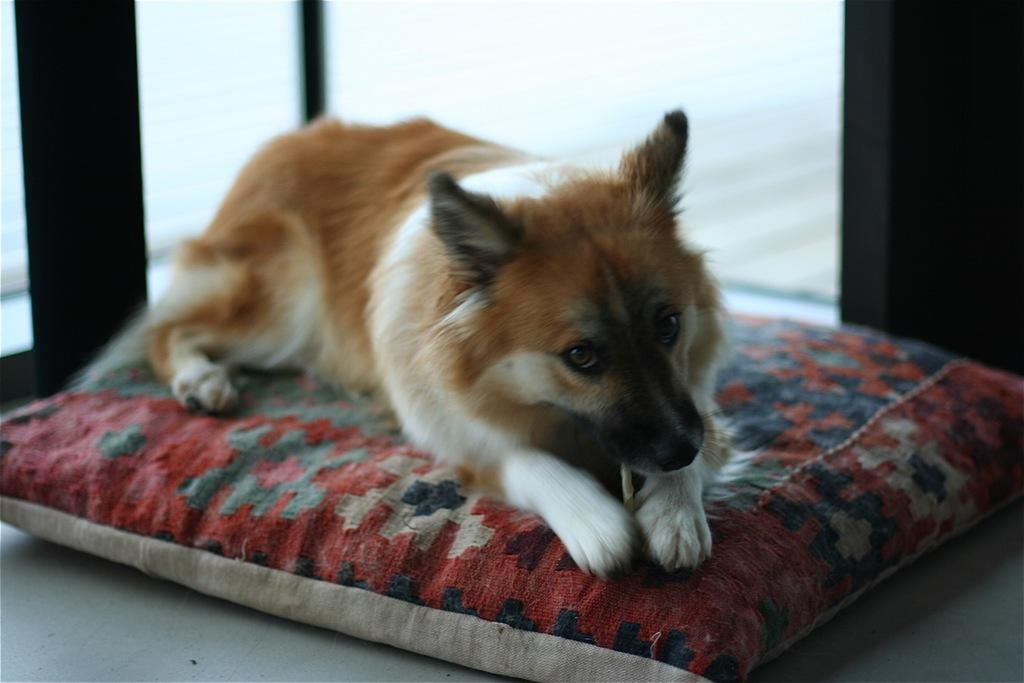What animal can be seen in the image? There is a dog in the image. Where is the dog sitting? The dog is sitting on a cushion. What is visible in the background of the image? There is a door in the background of the image. What is the cushion placed on? The cushion is placed on the floor. What type of crime is the dog investigating in the image? There is no crime or investigation depicted in the image; it simply shows a dog sitting on a cushion. 